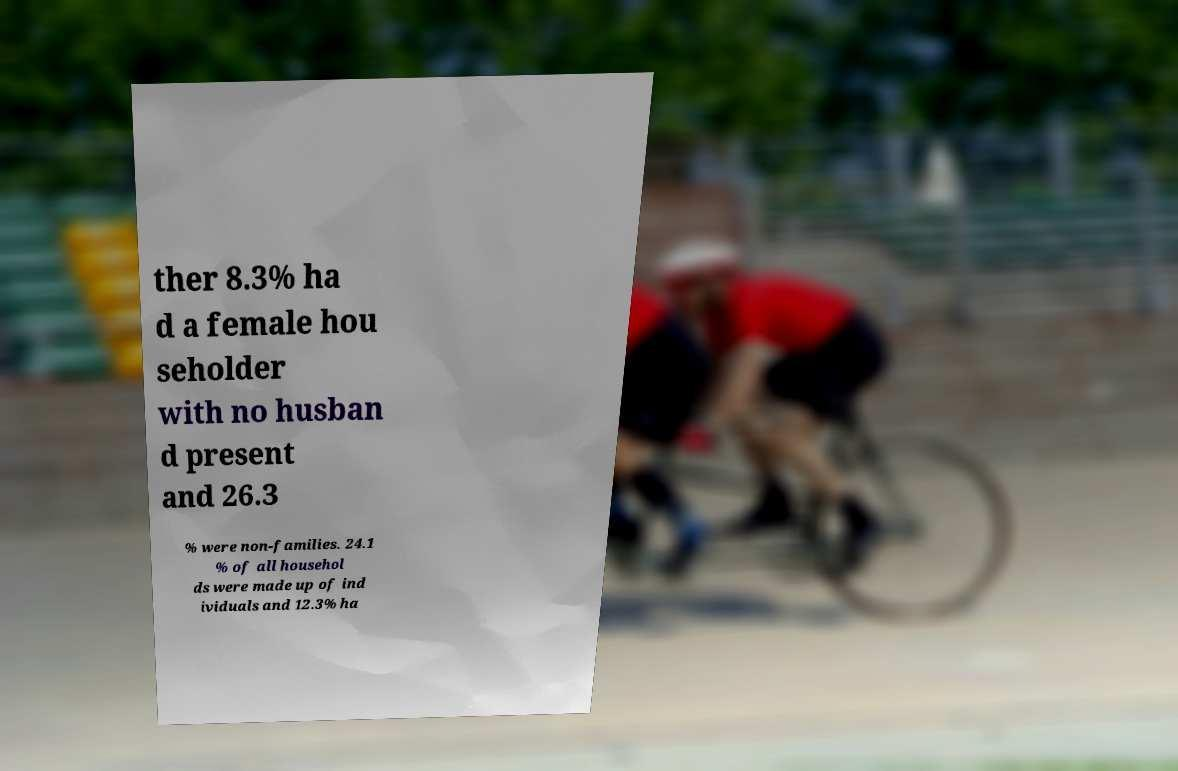Can you read and provide the text displayed in the image?This photo seems to have some interesting text. Can you extract and type it out for me? ther 8.3% ha d a female hou seholder with no husban d present and 26.3 % were non-families. 24.1 % of all househol ds were made up of ind ividuals and 12.3% ha 